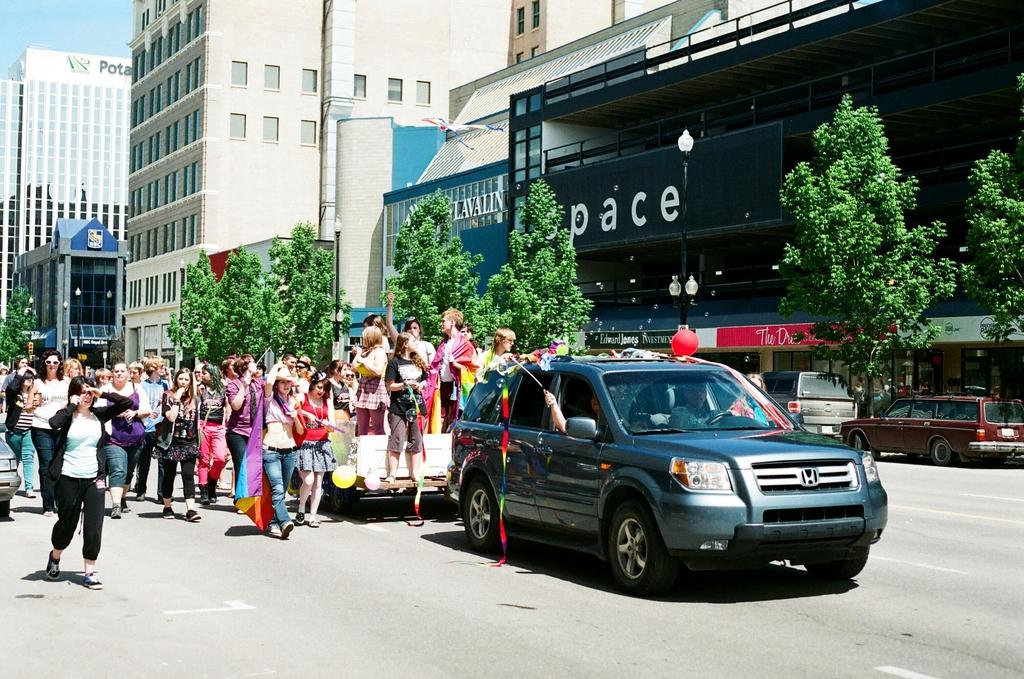What are the people in the image doing? There are many people standing and walking on the road in the image. What is moving in front of the people? A car is moving in front of the people in the image. What can be seen in the background of the image? There are buildings and trees in the background of the image. What else is visible in front of the buildings? Vehicles are visible in front of the buildings in the image. What direction is the head of the car facing in the image? The image does not show the head of a car; it shows a car moving in front of the people. What knowledge is being shared among the people in the image? The image does not depict any knowledge being shared among the people; they are simply standing and walking on the road. 